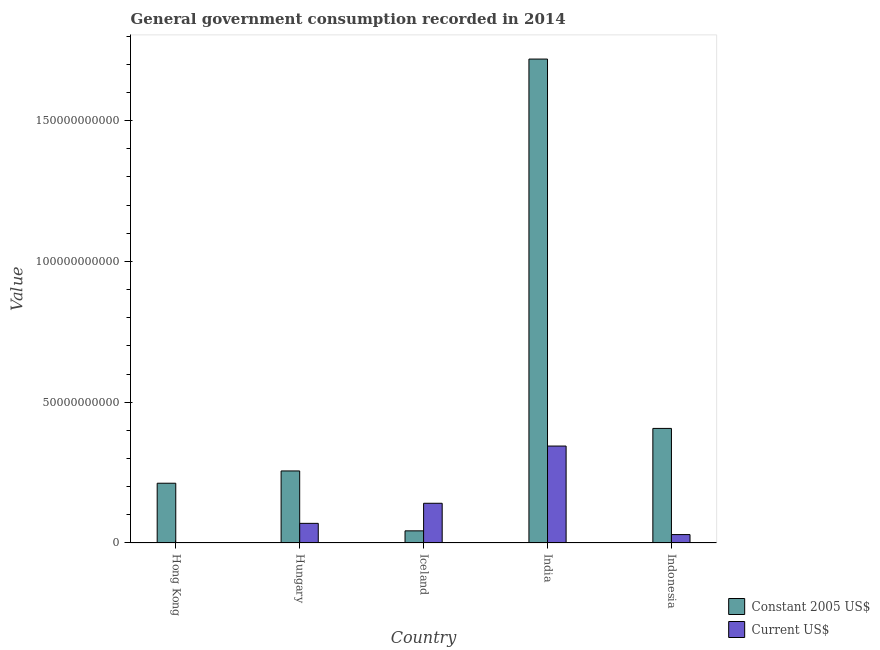Are the number of bars on each tick of the X-axis equal?
Your response must be concise. Yes. What is the value consumed in constant 2005 us$ in Hong Kong?
Offer a terse response. 2.12e+1. Across all countries, what is the maximum value consumed in current us$?
Offer a very short reply. 3.44e+1. Across all countries, what is the minimum value consumed in constant 2005 us$?
Your answer should be very brief. 4.31e+09. In which country was the value consumed in current us$ minimum?
Give a very brief answer. Hong Kong. What is the total value consumed in constant 2005 us$ in the graph?
Provide a succinct answer. 2.64e+11. What is the difference between the value consumed in current us$ in Hungary and that in Indonesia?
Provide a short and direct response. 3.99e+09. What is the difference between the value consumed in constant 2005 us$ in Iceland and the value consumed in current us$ in India?
Ensure brevity in your answer.  -3.01e+1. What is the average value consumed in current us$ per country?
Keep it short and to the point. 1.17e+1. What is the difference between the value consumed in current us$ and value consumed in constant 2005 us$ in Hong Kong?
Your answer should be very brief. -2.11e+1. In how many countries, is the value consumed in constant 2005 us$ greater than 60000000000 ?
Make the answer very short. 1. What is the ratio of the value consumed in current us$ in Hungary to that in Iceland?
Offer a very short reply. 0.49. Is the difference between the value consumed in constant 2005 us$ in Hungary and Indonesia greater than the difference between the value consumed in current us$ in Hungary and Indonesia?
Provide a succinct answer. No. What is the difference between the highest and the second highest value consumed in constant 2005 us$?
Your response must be concise. 1.31e+11. What is the difference between the highest and the lowest value consumed in constant 2005 us$?
Your response must be concise. 1.68e+11. Is the sum of the value consumed in current us$ in Hungary and Iceland greater than the maximum value consumed in constant 2005 us$ across all countries?
Ensure brevity in your answer.  No. What does the 2nd bar from the left in Hong Kong represents?
Give a very brief answer. Current US$. What does the 1st bar from the right in India represents?
Your answer should be very brief. Current US$. How many bars are there?
Ensure brevity in your answer.  10. Are all the bars in the graph horizontal?
Give a very brief answer. No. Are the values on the major ticks of Y-axis written in scientific E-notation?
Keep it short and to the point. No. Does the graph contain any zero values?
Offer a terse response. No. Does the graph contain grids?
Provide a short and direct response. No. How many legend labels are there?
Your response must be concise. 2. How are the legend labels stacked?
Give a very brief answer. Vertical. What is the title of the graph?
Give a very brief answer. General government consumption recorded in 2014. Does "Health Care" appear as one of the legend labels in the graph?
Your answer should be compact. No. What is the label or title of the Y-axis?
Your answer should be compact. Value. What is the Value in Constant 2005 US$ in Hong Kong?
Provide a succinct answer. 2.12e+1. What is the Value of Current US$ in Hong Kong?
Ensure brevity in your answer.  1.04e+08. What is the Value in Constant 2005 US$ in Hungary?
Give a very brief answer. 2.56e+1. What is the Value in Current US$ in Hungary?
Make the answer very short. 6.98e+09. What is the Value in Constant 2005 US$ in Iceland?
Provide a succinct answer. 4.31e+09. What is the Value in Current US$ in Iceland?
Provide a succinct answer. 1.41e+1. What is the Value in Constant 2005 US$ in India?
Keep it short and to the point. 1.72e+11. What is the Value in Current US$ in India?
Offer a very short reply. 3.44e+1. What is the Value in Constant 2005 US$ in Indonesia?
Your response must be concise. 4.07e+1. What is the Value in Current US$ in Indonesia?
Keep it short and to the point. 2.99e+09. Across all countries, what is the maximum Value in Constant 2005 US$?
Keep it short and to the point. 1.72e+11. Across all countries, what is the maximum Value of Current US$?
Offer a terse response. 3.44e+1. Across all countries, what is the minimum Value in Constant 2005 US$?
Offer a terse response. 4.31e+09. Across all countries, what is the minimum Value in Current US$?
Provide a succinct answer. 1.04e+08. What is the total Value of Constant 2005 US$ in the graph?
Make the answer very short. 2.64e+11. What is the total Value of Current US$ in the graph?
Your response must be concise. 5.86e+1. What is the difference between the Value of Constant 2005 US$ in Hong Kong and that in Hungary?
Give a very brief answer. -4.36e+09. What is the difference between the Value in Current US$ in Hong Kong and that in Hungary?
Provide a short and direct response. -6.87e+09. What is the difference between the Value in Constant 2005 US$ in Hong Kong and that in Iceland?
Your answer should be compact. 1.69e+1. What is the difference between the Value of Current US$ in Hong Kong and that in Iceland?
Your answer should be very brief. -1.40e+1. What is the difference between the Value in Constant 2005 US$ in Hong Kong and that in India?
Keep it short and to the point. -1.51e+11. What is the difference between the Value of Current US$ in Hong Kong and that in India?
Your answer should be very brief. -3.43e+1. What is the difference between the Value in Constant 2005 US$ in Hong Kong and that in Indonesia?
Ensure brevity in your answer.  -1.95e+1. What is the difference between the Value in Current US$ in Hong Kong and that in Indonesia?
Ensure brevity in your answer.  -2.88e+09. What is the difference between the Value in Constant 2005 US$ in Hungary and that in Iceland?
Give a very brief answer. 2.13e+1. What is the difference between the Value in Current US$ in Hungary and that in Iceland?
Give a very brief answer. -7.13e+09. What is the difference between the Value in Constant 2005 US$ in Hungary and that in India?
Give a very brief answer. -1.46e+11. What is the difference between the Value of Current US$ in Hungary and that in India?
Provide a short and direct response. -2.75e+1. What is the difference between the Value of Constant 2005 US$ in Hungary and that in Indonesia?
Your answer should be compact. -1.51e+1. What is the difference between the Value in Current US$ in Hungary and that in Indonesia?
Keep it short and to the point. 3.99e+09. What is the difference between the Value in Constant 2005 US$ in Iceland and that in India?
Make the answer very short. -1.68e+11. What is the difference between the Value of Current US$ in Iceland and that in India?
Provide a short and direct response. -2.03e+1. What is the difference between the Value in Constant 2005 US$ in Iceland and that in Indonesia?
Your answer should be compact. -3.64e+1. What is the difference between the Value of Current US$ in Iceland and that in Indonesia?
Make the answer very short. 1.11e+1. What is the difference between the Value of Constant 2005 US$ in India and that in Indonesia?
Provide a succinct answer. 1.31e+11. What is the difference between the Value of Current US$ in India and that in Indonesia?
Give a very brief answer. 3.14e+1. What is the difference between the Value in Constant 2005 US$ in Hong Kong and the Value in Current US$ in Hungary?
Ensure brevity in your answer.  1.42e+1. What is the difference between the Value in Constant 2005 US$ in Hong Kong and the Value in Current US$ in Iceland?
Your response must be concise. 7.12e+09. What is the difference between the Value of Constant 2005 US$ in Hong Kong and the Value of Current US$ in India?
Your answer should be very brief. -1.32e+1. What is the difference between the Value of Constant 2005 US$ in Hong Kong and the Value of Current US$ in Indonesia?
Provide a short and direct response. 1.82e+1. What is the difference between the Value of Constant 2005 US$ in Hungary and the Value of Current US$ in Iceland?
Your answer should be compact. 1.15e+1. What is the difference between the Value of Constant 2005 US$ in Hungary and the Value of Current US$ in India?
Offer a terse response. -8.84e+09. What is the difference between the Value of Constant 2005 US$ in Hungary and the Value of Current US$ in Indonesia?
Your answer should be very brief. 2.26e+1. What is the difference between the Value of Constant 2005 US$ in Iceland and the Value of Current US$ in India?
Provide a succinct answer. -3.01e+1. What is the difference between the Value in Constant 2005 US$ in Iceland and the Value in Current US$ in Indonesia?
Offer a terse response. 1.33e+09. What is the difference between the Value of Constant 2005 US$ in India and the Value of Current US$ in Indonesia?
Give a very brief answer. 1.69e+11. What is the average Value of Constant 2005 US$ per country?
Your answer should be compact. 5.27e+1. What is the average Value of Current US$ per country?
Keep it short and to the point. 1.17e+1. What is the difference between the Value in Constant 2005 US$ and Value in Current US$ in Hong Kong?
Offer a terse response. 2.11e+1. What is the difference between the Value in Constant 2005 US$ and Value in Current US$ in Hungary?
Offer a terse response. 1.86e+1. What is the difference between the Value in Constant 2005 US$ and Value in Current US$ in Iceland?
Offer a very short reply. -9.80e+09. What is the difference between the Value of Constant 2005 US$ and Value of Current US$ in India?
Keep it short and to the point. 1.37e+11. What is the difference between the Value in Constant 2005 US$ and Value in Current US$ in Indonesia?
Provide a succinct answer. 3.77e+1. What is the ratio of the Value of Constant 2005 US$ in Hong Kong to that in Hungary?
Make the answer very short. 0.83. What is the ratio of the Value in Current US$ in Hong Kong to that in Hungary?
Offer a very short reply. 0.01. What is the ratio of the Value in Constant 2005 US$ in Hong Kong to that in Iceland?
Offer a terse response. 4.92. What is the ratio of the Value in Current US$ in Hong Kong to that in Iceland?
Give a very brief answer. 0.01. What is the ratio of the Value in Constant 2005 US$ in Hong Kong to that in India?
Your answer should be very brief. 0.12. What is the ratio of the Value in Current US$ in Hong Kong to that in India?
Offer a terse response. 0. What is the ratio of the Value in Constant 2005 US$ in Hong Kong to that in Indonesia?
Provide a succinct answer. 0.52. What is the ratio of the Value in Current US$ in Hong Kong to that in Indonesia?
Provide a short and direct response. 0.03. What is the ratio of the Value of Constant 2005 US$ in Hungary to that in Iceland?
Make the answer very short. 5.93. What is the ratio of the Value in Current US$ in Hungary to that in Iceland?
Offer a very short reply. 0.49. What is the ratio of the Value of Constant 2005 US$ in Hungary to that in India?
Your answer should be compact. 0.15. What is the ratio of the Value of Current US$ in Hungary to that in India?
Provide a short and direct response. 0.2. What is the ratio of the Value in Constant 2005 US$ in Hungary to that in Indonesia?
Provide a short and direct response. 0.63. What is the ratio of the Value of Current US$ in Hungary to that in Indonesia?
Your response must be concise. 2.34. What is the ratio of the Value in Constant 2005 US$ in Iceland to that in India?
Keep it short and to the point. 0.03. What is the ratio of the Value of Current US$ in Iceland to that in India?
Your response must be concise. 0.41. What is the ratio of the Value in Constant 2005 US$ in Iceland to that in Indonesia?
Your answer should be compact. 0.11. What is the ratio of the Value in Current US$ in Iceland to that in Indonesia?
Make the answer very short. 4.72. What is the ratio of the Value of Constant 2005 US$ in India to that in Indonesia?
Offer a terse response. 4.22. What is the ratio of the Value in Current US$ in India to that in Indonesia?
Provide a succinct answer. 11.53. What is the difference between the highest and the second highest Value of Constant 2005 US$?
Offer a very short reply. 1.31e+11. What is the difference between the highest and the second highest Value of Current US$?
Keep it short and to the point. 2.03e+1. What is the difference between the highest and the lowest Value in Constant 2005 US$?
Provide a short and direct response. 1.68e+11. What is the difference between the highest and the lowest Value in Current US$?
Your answer should be very brief. 3.43e+1. 